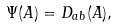<formula> <loc_0><loc_0><loc_500><loc_500>\Psi ( A ) = D _ { a b } ( A ) ,</formula> 